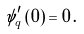<formula> <loc_0><loc_0><loc_500><loc_500>\psi _ { q } ^ { \prime } \left ( 0 \right ) = 0 \, .</formula> 